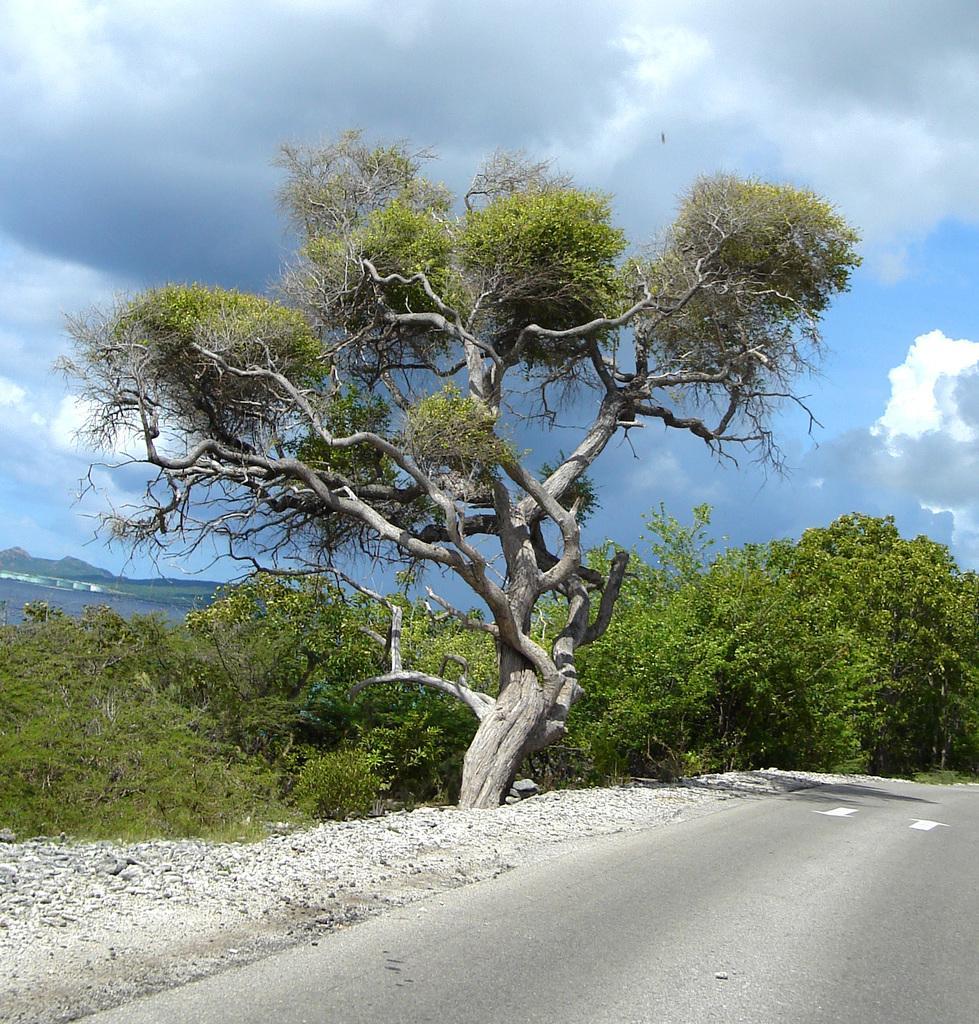Describe this image in one or two sentences. This picture shows few trees and we see water and a blue cloudy sky. 